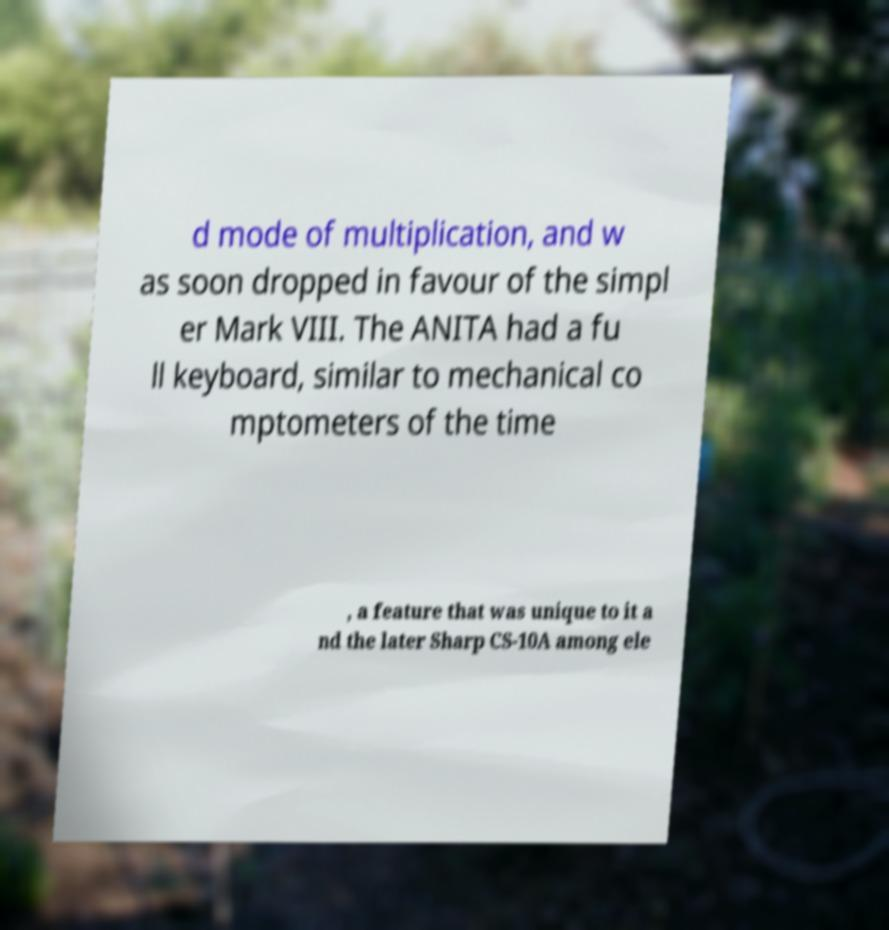For documentation purposes, I need the text within this image transcribed. Could you provide that? d mode of multiplication, and w as soon dropped in favour of the simpl er Mark VIII. The ANITA had a fu ll keyboard, similar to mechanical co mptometers of the time , a feature that was unique to it a nd the later Sharp CS-10A among ele 